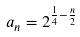<formula> <loc_0><loc_0><loc_500><loc_500>a _ { n } = 2 ^ { \frac { 1 } { 4 } - \frac { n } { 2 } }</formula> 